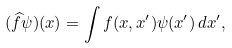Convert formula to latex. <formula><loc_0><loc_0><loc_500><loc_500>( \widehat { f } \psi ) ( x ) = \int f ( x , x ^ { \prime } ) \psi ( x ^ { \prime } ) \, d x ^ { \prime } ,</formula> 